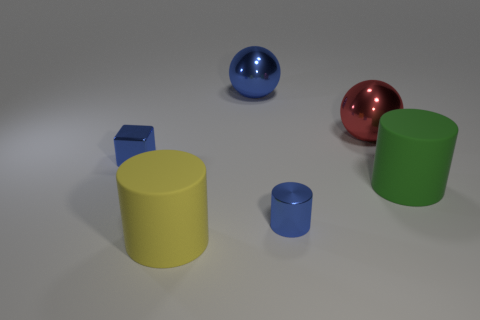Is the material of the cylinder that is behind the metallic cylinder the same as the large cylinder to the left of the green cylinder? yes 